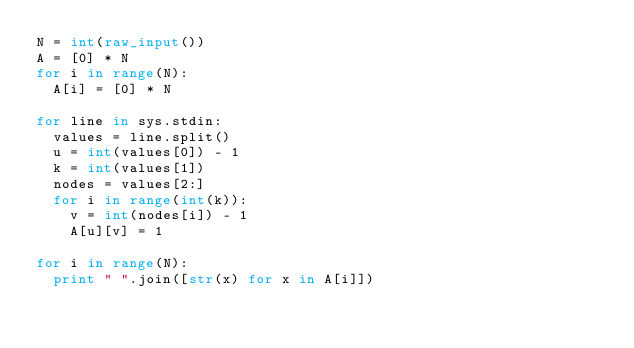<code> <loc_0><loc_0><loc_500><loc_500><_Python_>N = int(raw_input())
A = [0] * N
for i in range(N):
  A[i] = [0] * N

for line in sys.stdin:
  values = line.split()
  u = int(values[0]) - 1
  k = int(values[1])
  nodes = values[2:]
  for i in range(int(k)):
    v = int(nodes[i]) - 1
    A[u][v] = 1

for i in range(N):
  print " ".join([str(x) for x in A[i]])</code> 